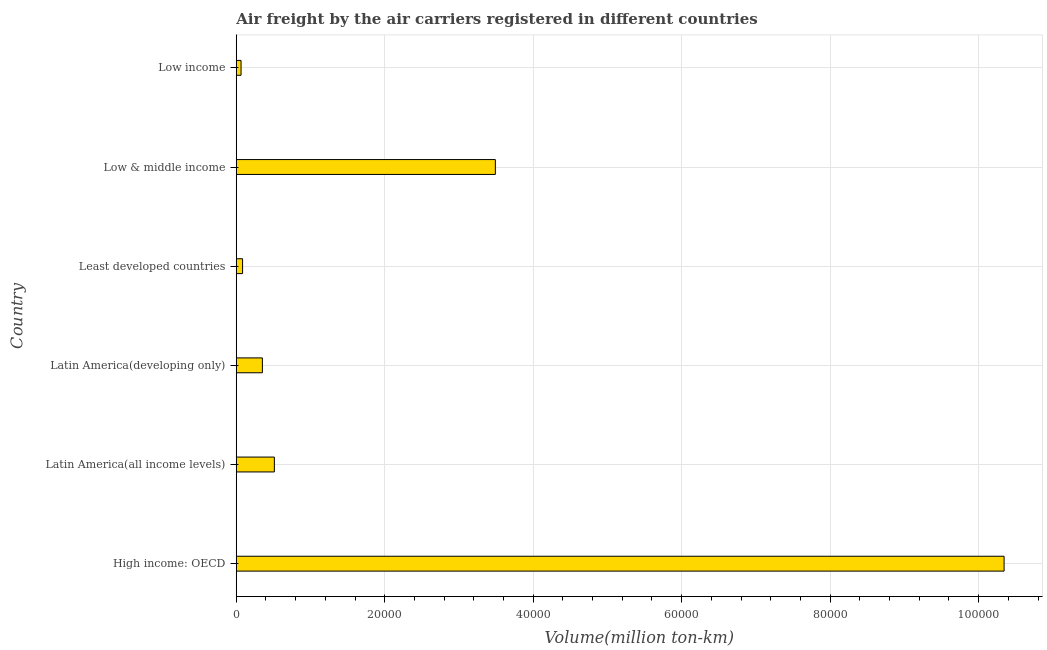What is the title of the graph?
Provide a succinct answer. Air freight by the air carriers registered in different countries. What is the label or title of the X-axis?
Provide a short and direct response. Volume(million ton-km). What is the air freight in High income: OECD?
Give a very brief answer. 1.03e+05. Across all countries, what is the maximum air freight?
Keep it short and to the point. 1.03e+05. Across all countries, what is the minimum air freight?
Provide a succinct answer. 645.72. In which country was the air freight maximum?
Ensure brevity in your answer.  High income: OECD. What is the sum of the air freight?
Offer a terse response. 1.48e+05. What is the difference between the air freight in Low & middle income and Low income?
Provide a short and direct response. 3.43e+04. What is the average air freight per country?
Give a very brief answer. 2.47e+04. What is the median air freight?
Make the answer very short. 4326.8. What is the ratio of the air freight in Latin America(all income levels) to that in Least developed countries?
Ensure brevity in your answer.  6.03. What is the difference between the highest and the second highest air freight?
Your answer should be compact. 6.85e+04. What is the difference between the highest and the lowest air freight?
Provide a succinct answer. 1.03e+05. How many bars are there?
Offer a terse response. 6. What is the difference between two consecutive major ticks on the X-axis?
Make the answer very short. 2.00e+04. What is the Volume(million ton-km) in High income: OECD?
Your answer should be very brief. 1.03e+05. What is the Volume(million ton-km) of Latin America(all income levels)?
Your answer should be very brief. 5132.96. What is the Volume(million ton-km) of Latin America(developing only)?
Offer a terse response. 3520.63. What is the Volume(million ton-km) of Least developed countries?
Your answer should be very brief. 851.47. What is the Volume(million ton-km) in Low & middle income?
Keep it short and to the point. 3.49e+04. What is the Volume(million ton-km) in Low income?
Ensure brevity in your answer.  645.72. What is the difference between the Volume(million ton-km) in High income: OECD and Latin America(all income levels)?
Your answer should be compact. 9.83e+04. What is the difference between the Volume(million ton-km) in High income: OECD and Latin America(developing only)?
Offer a terse response. 9.99e+04. What is the difference between the Volume(million ton-km) in High income: OECD and Least developed countries?
Offer a terse response. 1.03e+05. What is the difference between the Volume(million ton-km) in High income: OECD and Low & middle income?
Your answer should be very brief. 6.85e+04. What is the difference between the Volume(million ton-km) in High income: OECD and Low income?
Keep it short and to the point. 1.03e+05. What is the difference between the Volume(million ton-km) in Latin America(all income levels) and Latin America(developing only)?
Offer a very short reply. 1612.33. What is the difference between the Volume(million ton-km) in Latin America(all income levels) and Least developed countries?
Provide a short and direct response. 4281.49. What is the difference between the Volume(million ton-km) in Latin America(all income levels) and Low & middle income?
Make the answer very short. -2.98e+04. What is the difference between the Volume(million ton-km) in Latin America(all income levels) and Low income?
Keep it short and to the point. 4487.24. What is the difference between the Volume(million ton-km) in Latin America(developing only) and Least developed countries?
Keep it short and to the point. 2669.16. What is the difference between the Volume(million ton-km) in Latin America(developing only) and Low & middle income?
Ensure brevity in your answer.  -3.14e+04. What is the difference between the Volume(million ton-km) in Latin America(developing only) and Low income?
Your response must be concise. 2874.91. What is the difference between the Volume(million ton-km) in Least developed countries and Low & middle income?
Offer a terse response. -3.41e+04. What is the difference between the Volume(million ton-km) in Least developed countries and Low income?
Make the answer very short. 205.75. What is the difference between the Volume(million ton-km) in Low & middle income and Low income?
Offer a terse response. 3.43e+04. What is the ratio of the Volume(million ton-km) in High income: OECD to that in Latin America(all income levels)?
Make the answer very short. 20.15. What is the ratio of the Volume(million ton-km) in High income: OECD to that in Latin America(developing only)?
Your answer should be compact. 29.38. What is the ratio of the Volume(million ton-km) in High income: OECD to that in Least developed countries?
Provide a succinct answer. 121.48. What is the ratio of the Volume(million ton-km) in High income: OECD to that in Low & middle income?
Ensure brevity in your answer.  2.96. What is the ratio of the Volume(million ton-km) in High income: OECD to that in Low income?
Ensure brevity in your answer.  160.18. What is the ratio of the Volume(million ton-km) in Latin America(all income levels) to that in Latin America(developing only)?
Your answer should be very brief. 1.46. What is the ratio of the Volume(million ton-km) in Latin America(all income levels) to that in Least developed countries?
Ensure brevity in your answer.  6.03. What is the ratio of the Volume(million ton-km) in Latin America(all income levels) to that in Low & middle income?
Provide a succinct answer. 0.15. What is the ratio of the Volume(million ton-km) in Latin America(all income levels) to that in Low income?
Your answer should be very brief. 7.95. What is the ratio of the Volume(million ton-km) in Latin America(developing only) to that in Least developed countries?
Give a very brief answer. 4.13. What is the ratio of the Volume(million ton-km) in Latin America(developing only) to that in Low & middle income?
Offer a terse response. 0.1. What is the ratio of the Volume(million ton-km) in Latin America(developing only) to that in Low income?
Make the answer very short. 5.45. What is the ratio of the Volume(million ton-km) in Least developed countries to that in Low & middle income?
Offer a very short reply. 0.02. What is the ratio of the Volume(million ton-km) in Least developed countries to that in Low income?
Provide a short and direct response. 1.32. What is the ratio of the Volume(million ton-km) in Low & middle income to that in Low income?
Make the answer very short. 54.05. 